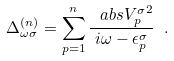<formula> <loc_0><loc_0><loc_500><loc_500>\Delta ^ { ( n ) } _ { \omega \sigma } = \sum _ { p = 1 } ^ { n } \frac { \ a b s { V ^ { \sigma } _ { p } } ^ { 2 } } { i \omega - \epsilon ^ { \sigma } _ { p } } \ .</formula> 